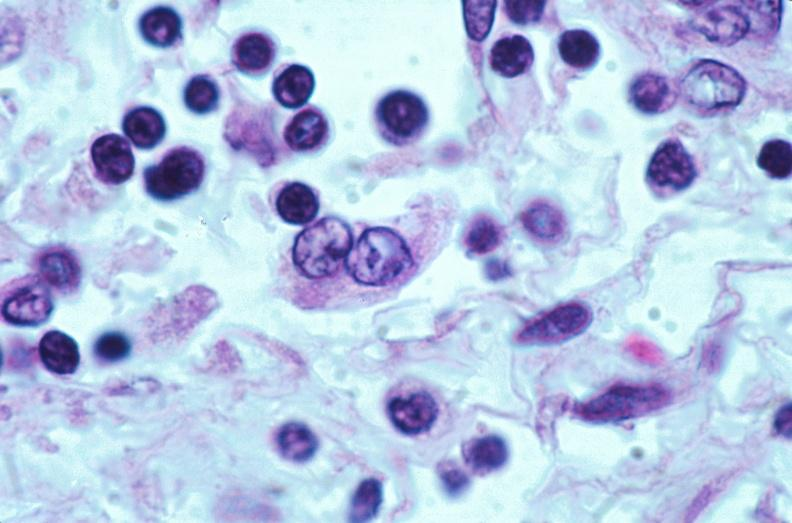what does this image show?
Answer the question using a single word or phrase. Lymph nodes 